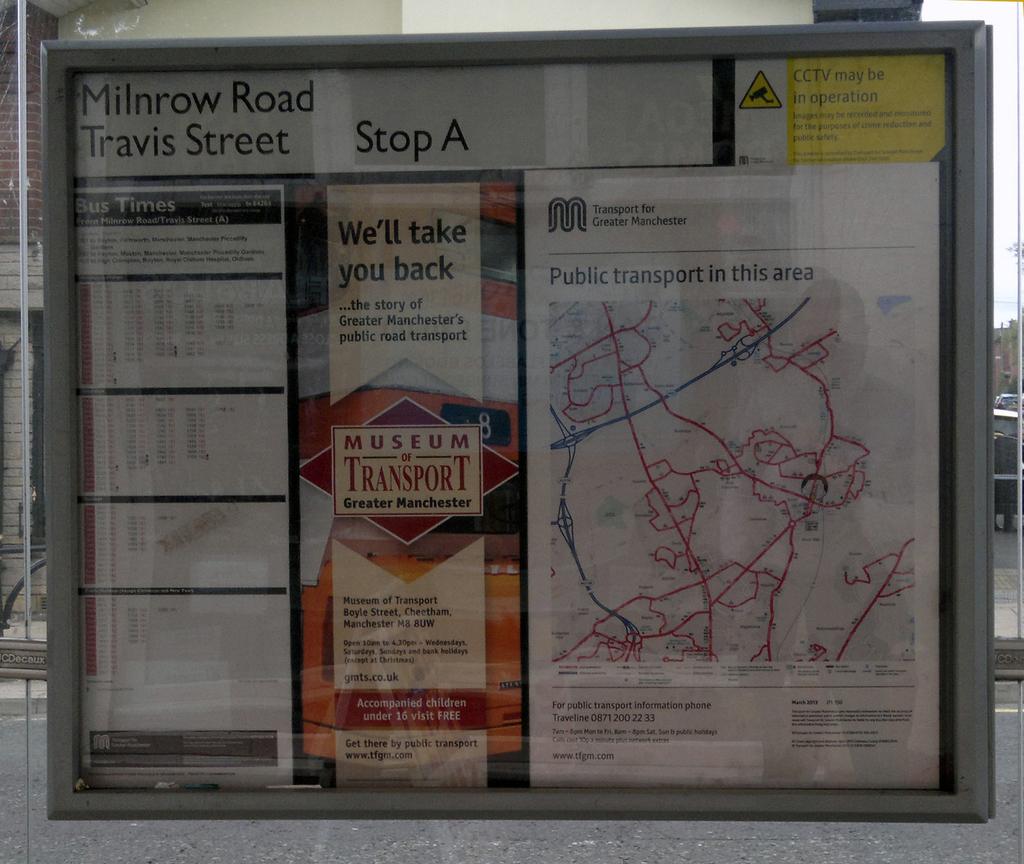What stop does it say in the top center of the display?
Your answer should be compact. A. What city is this in?
Ensure brevity in your answer.  Manchester. 